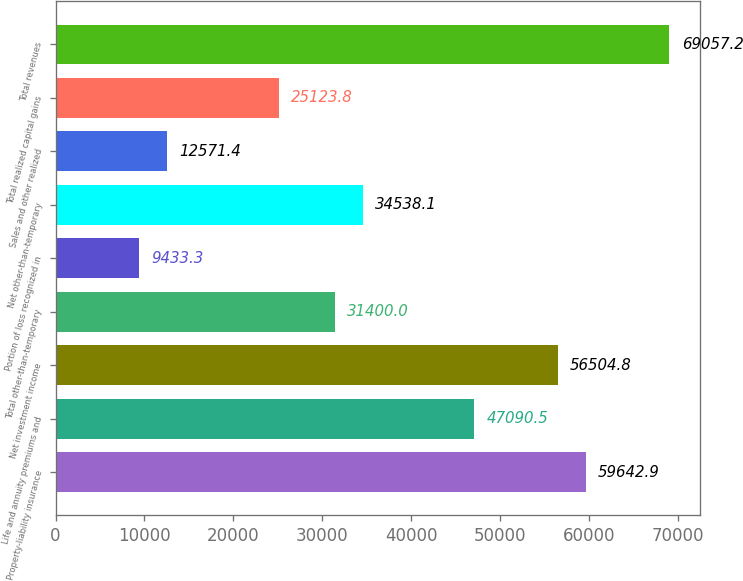<chart> <loc_0><loc_0><loc_500><loc_500><bar_chart><fcel>Property-liability insurance<fcel>Life and annuity premiums and<fcel>Net investment income<fcel>Total other-than-temporary<fcel>Portion of loss recognized in<fcel>Net other-than-temporary<fcel>Sales and other realized<fcel>Total realized capital gains<fcel>Total revenues<nl><fcel>59642.9<fcel>47090.5<fcel>56504.8<fcel>31400<fcel>9433.3<fcel>34538.1<fcel>12571.4<fcel>25123.8<fcel>69057.2<nl></chart> 